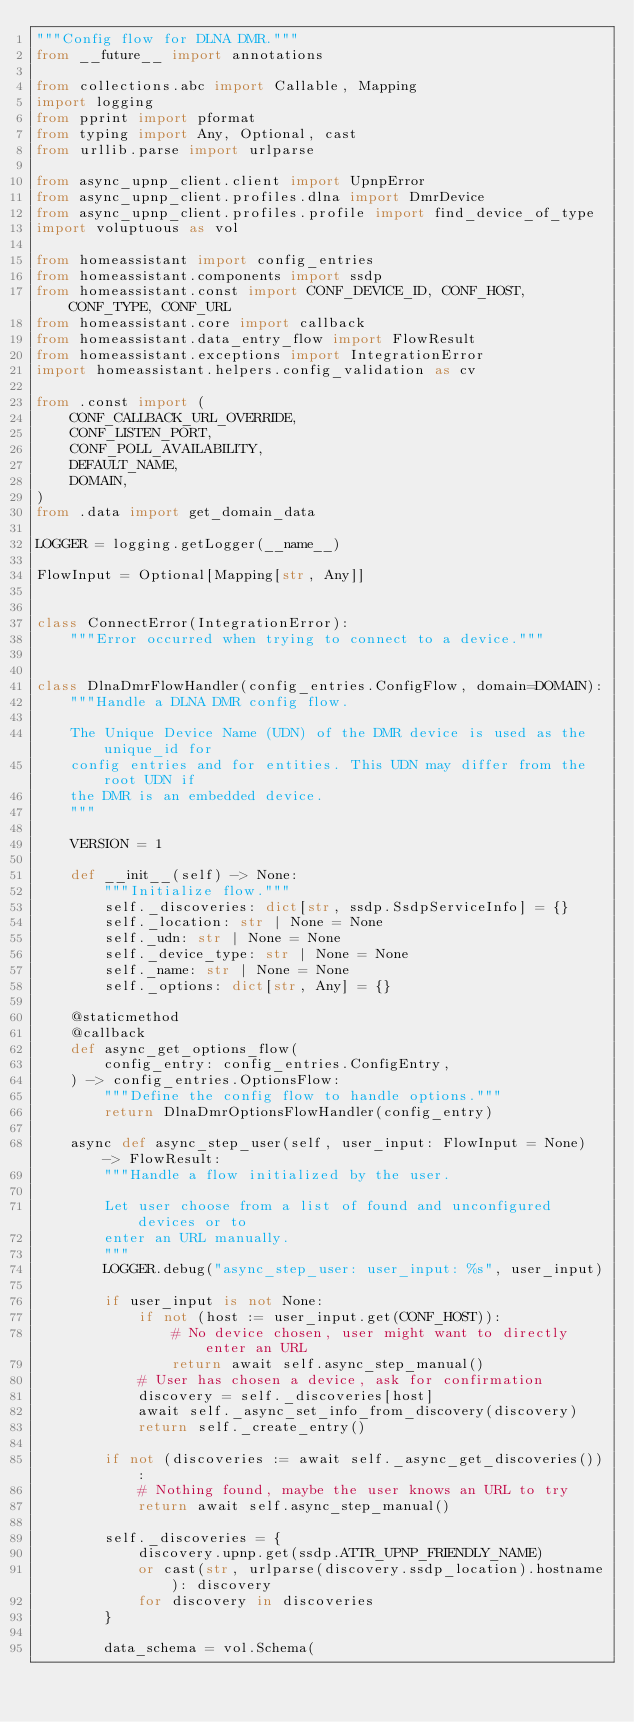<code> <loc_0><loc_0><loc_500><loc_500><_Python_>"""Config flow for DLNA DMR."""
from __future__ import annotations

from collections.abc import Callable, Mapping
import logging
from pprint import pformat
from typing import Any, Optional, cast
from urllib.parse import urlparse

from async_upnp_client.client import UpnpError
from async_upnp_client.profiles.dlna import DmrDevice
from async_upnp_client.profiles.profile import find_device_of_type
import voluptuous as vol

from homeassistant import config_entries
from homeassistant.components import ssdp
from homeassistant.const import CONF_DEVICE_ID, CONF_HOST, CONF_TYPE, CONF_URL
from homeassistant.core import callback
from homeassistant.data_entry_flow import FlowResult
from homeassistant.exceptions import IntegrationError
import homeassistant.helpers.config_validation as cv

from .const import (
    CONF_CALLBACK_URL_OVERRIDE,
    CONF_LISTEN_PORT,
    CONF_POLL_AVAILABILITY,
    DEFAULT_NAME,
    DOMAIN,
)
from .data import get_domain_data

LOGGER = logging.getLogger(__name__)

FlowInput = Optional[Mapping[str, Any]]


class ConnectError(IntegrationError):
    """Error occurred when trying to connect to a device."""


class DlnaDmrFlowHandler(config_entries.ConfigFlow, domain=DOMAIN):
    """Handle a DLNA DMR config flow.

    The Unique Device Name (UDN) of the DMR device is used as the unique_id for
    config entries and for entities. This UDN may differ from the root UDN if
    the DMR is an embedded device.
    """

    VERSION = 1

    def __init__(self) -> None:
        """Initialize flow."""
        self._discoveries: dict[str, ssdp.SsdpServiceInfo] = {}
        self._location: str | None = None
        self._udn: str | None = None
        self._device_type: str | None = None
        self._name: str | None = None
        self._options: dict[str, Any] = {}

    @staticmethod
    @callback
    def async_get_options_flow(
        config_entry: config_entries.ConfigEntry,
    ) -> config_entries.OptionsFlow:
        """Define the config flow to handle options."""
        return DlnaDmrOptionsFlowHandler(config_entry)

    async def async_step_user(self, user_input: FlowInput = None) -> FlowResult:
        """Handle a flow initialized by the user.

        Let user choose from a list of found and unconfigured devices or to
        enter an URL manually.
        """
        LOGGER.debug("async_step_user: user_input: %s", user_input)

        if user_input is not None:
            if not (host := user_input.get(CONF_HOST)):
                # No device chosen, user might want to directly enter an URL
                return await self.async_step_manual()
            # User has chosen a device, ask for confirmation
            discovery = self._discoveries[host]
            await self._async_set_info_from_discovery(discovery)
            return self._create_entry()

        if not (discoveries := await self._async_get_discoveries()):
            # Nothing found, maybe the user knows an URL to try
            return await self.async_step_manual()

        self._discoveries = {
            discovery.upnp.get(ssdp.ATTR_UPNP_FRIENDLY_NAME)
            or cast(str, urlparse(discovery.ssdp_location).hostname): discovery
            for discovery in discoveries
        }

        data_schema = vol.Schema(</code> 